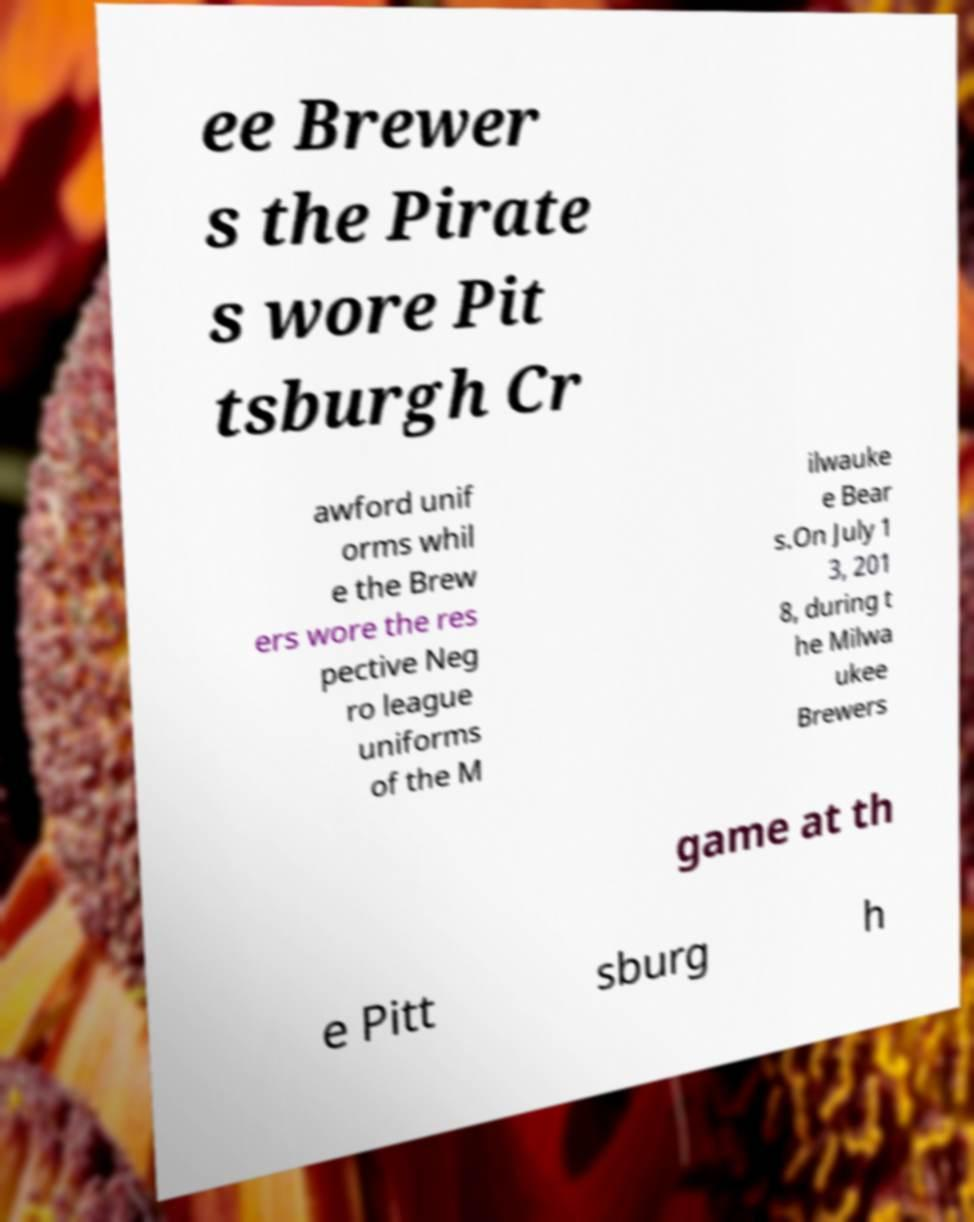Please identify and transcribe the text found in this image. ee Brewer s the Pirate s wore Pit tsburgh Cr awford unif orms whil e the Brew ers wore the res pective Neg ro league uniforms of the M ilwauke e Bear s.On July 1 3, 201 8, during t he Milwa ukee Brewers game at th e Pitt sburg h 